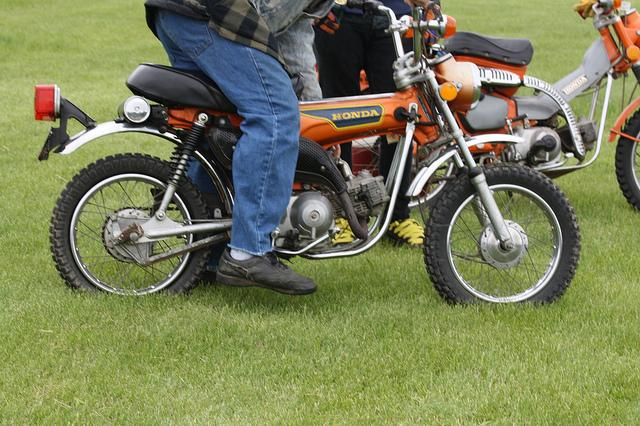What type of road are the small motorcycles created for? dirt 